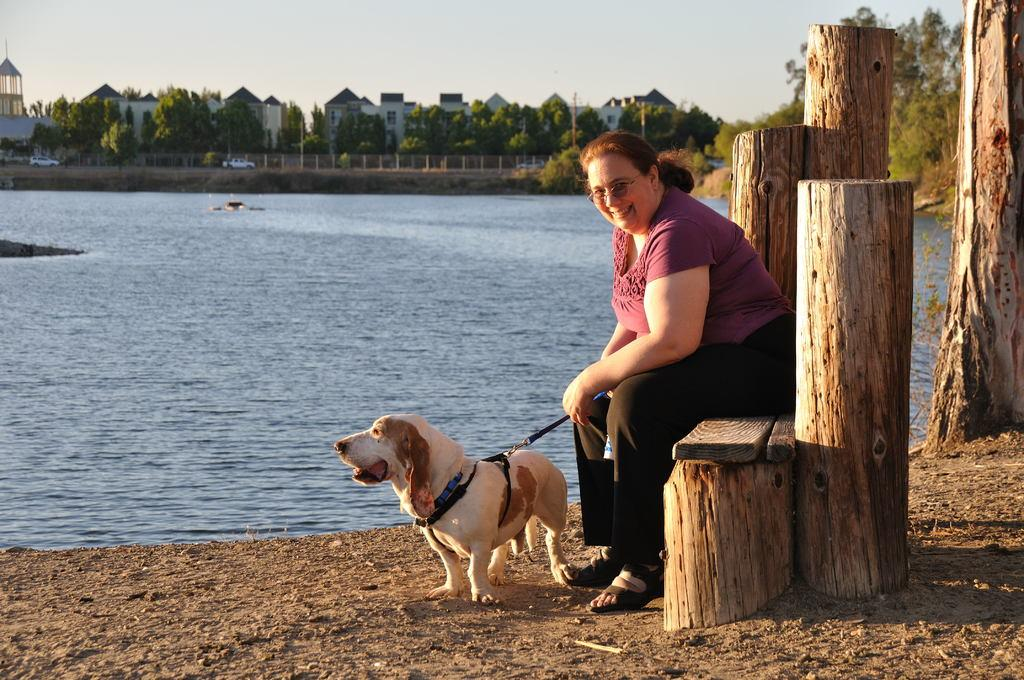What type of water body is shown in the image? The image depicts a freshwater river. What can be seen in the distance beyond the river? There are trees and buildings visible in the distance. What is the woman sitting on in the image? The woman is sitting on a system. What animal is in front of the woman? A dog is in front of the woman. What type of stone is the woman using to stitch the juice in the image? There is no stone, stitching, or juice present in the image. 